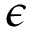Convert formula to latex. <formula><loc_0><loc_0><loc_500><loc_500>\epsilon</formula> 